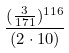Convert formula to latex. <formula><loc_0><loc_0><loc_500><loc_500>\frac { ( \frac { 3 } { 1 7 1 } ) ^ { 1 1 6 } } { ( 2 \cdot 1 0 ) }</formula> 